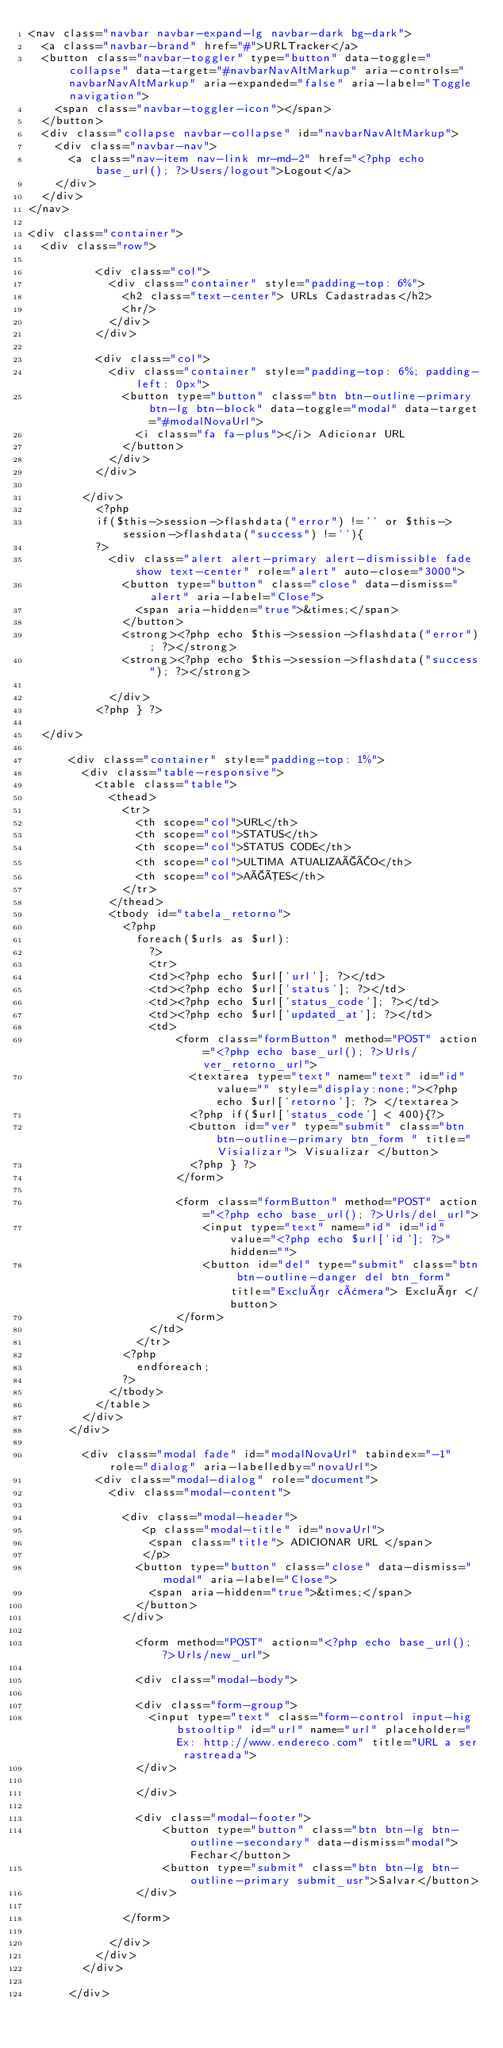<code> <loc_0><loc_0><loc_500><loc_500><_PHP_><nav class="navbar navbar-expand-lg navbar-dark bg-dark">
  <a class="navbar-brand" href="#">URLTracker</a>
  <button class="navbar-toggler" type="button" data-toggle="collapse" data-target="#navbarNavAltMarkup" aria-controls="navbarNavAltMarkup" aria-expanded="false" aria-label="Toggle navigation">
    <span class="navbar-toggler-icon"></span>
  </button>
  <div class="collapse navbar-collapse" id="navbarNavAltMarkup">
    <div class="navbar-nav">
      <a class="nav-item nav-link mr-md-2" href="<?php echo base_url(); ?>Users/logout">Logout</a>
    </div>
  </div>
</nav>

<div class="container">
  <div class="row">

          <div class="col">
            <div class="container" style="padding-top: 6%">
              <h2 class="text-center"> URLs Cadastradas</h2>
              <hr/>
            </div>
          </div>

          <div class="col">
            <div class="container" style="padding-top: 6%; padding-left: 0px">
              <button type="button" class="btn btn-outline-primary btn-lg btn-block" data-toggle="modal" data-target="#modalNovaUrl">
                <i class="fa fa-plus"></i> Adicionar URL
              </button>
            </div>
          </div>

        </div>
          <?php
          if($this->session->flashdata("error") !='' or $this->session->flashdata("success") !=''){
          ?>
            <div class="alert alert-primary alert-dismissible fade show text-center" role="alert" auto-close="3000">
              <button type="button" class="close" data-dismiss="alert" aria-label="Close">
                <span aria-hidden="true">&times;</span>
              </button>
              <strong><?php echo $this->session->flashdata("error"); ?></strong>
              <strong><?php echo $this->session->flashdata("success"); ?></strong>

            </div>
          <?php } ?>

  </div>

      <div class="container" style="padding-top: 1%">
        <div class="table-responsive">
          <table class="table">
            <thead>
              <tr>
                <th scope="col">URL</th>
                <th scope="col">STATUS</th>
                <th scope="col">STATUS CODE</th>
                <th scope="col">ULTIMA ATUALIZAÇÃO</th>
                <th scope="col">AÇÕES</th>
              </tr>
            </thead>
            <tbody id="tabela_retorno">
              <?php
                foreach($urls as $url):
                  ?>
                  <tr>
                  <td><?php echo $url['url']; ?></td>
                  <td><?php echo $url['status']; ?></td>
                  <td><?php echo $url['status_code']; ?></td>
                  <td><?php echo $url['updated_at']; ?></td>
                  <td>
                      <form class="formButton" method="POST" action="<?php echo base_url(); ?>Urls/ver_retorno_url">
                        <textarea type="text" name="text" id="id" value="" style="display:none;"><?php echo $url['retorno']; ?> </textarea>
                        <?php if($url['status_code'] < 400){?>
                        <button id="ver" type="submit" class="btn btn-outline-primary btn_form " title="Visializar"> Visualizar </button>
                        <?php } ?>
                      </form>

                      <form class="formButton" method="POST" action="<?php echo base_url(); ?>Urls/del_url">
                          <input type="text" name="id" id="id" value="<?php echo $url['id']; ?>" hidden="">
                          <button id="del" type="submit" class="btn btn-outline-danger del btn_form" title="Excluír câmera"> Excluír </button>
                      </form>
                  </td>
                </tr>
              <?php
                endforeach;
              ?>
            </tbody>
          </table>
        </div>
      </div>

        <div class="modal fade" id="modalNovaUrl" tabindex="-1" role="dialog" aria-labelledby="novaUrl">
          <div class="modal-dialog" role="document">
            <div class="modal-content">

              <div class="modal-header">
                 <p class="modal-title" id="novaUrl">
                  <span class="title"> ADICIONAR URL </span>
                 </p>
                <button type="button" class="close" data-dismiss="modal" aria-label="Close">
                  <span aria-hidden="true">&times;</span>
                </button>
              </div>

                <form method="POST" action="<?php echo base_url(); ?>Urls/new_url">

                <div class="modal-body">

                <div class="form-group">
                  <input type="text" class="form-control input-hig bstooltip" id="url" name="url" placeholder="Ex: http://www.endereco.com" title="URL a ser rastreada">
                </div>

                </div>

                <div class="modal-footer">
                    <button type="button" class="btn btn-lg btn-outline-secondary" data-dismiss="modal">Fechar</button>
                    <button type="submit" class="btn btn-lg btn-outline-primary submit_usr">Salvar</button>
                </div>

              </form>

            </div>
          </div>
        </div>

      </div></code> 